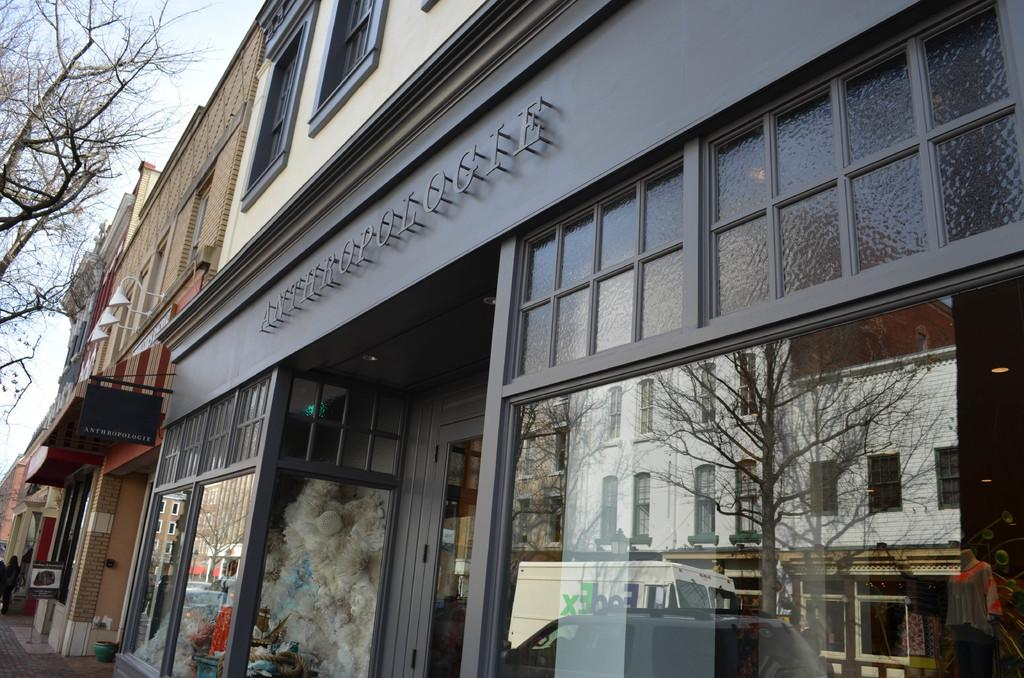What type of structure is depicted in the image? There is a building with windows in the image. What can be found inside the building? There are shops in the building. What is unique about the building's design? The building has glass walls. What other structures can be seen in the image? There are other buildings with pillars in the image. What natural element is visible in the image? A part of a tree is visible in the image. What is visible in the background of the image? The sky is visible in the image. How many fans are visible in the image? There are no fans present in the image. What type of cattle can be seen grazing near the building? There are no cattle present in the image. 